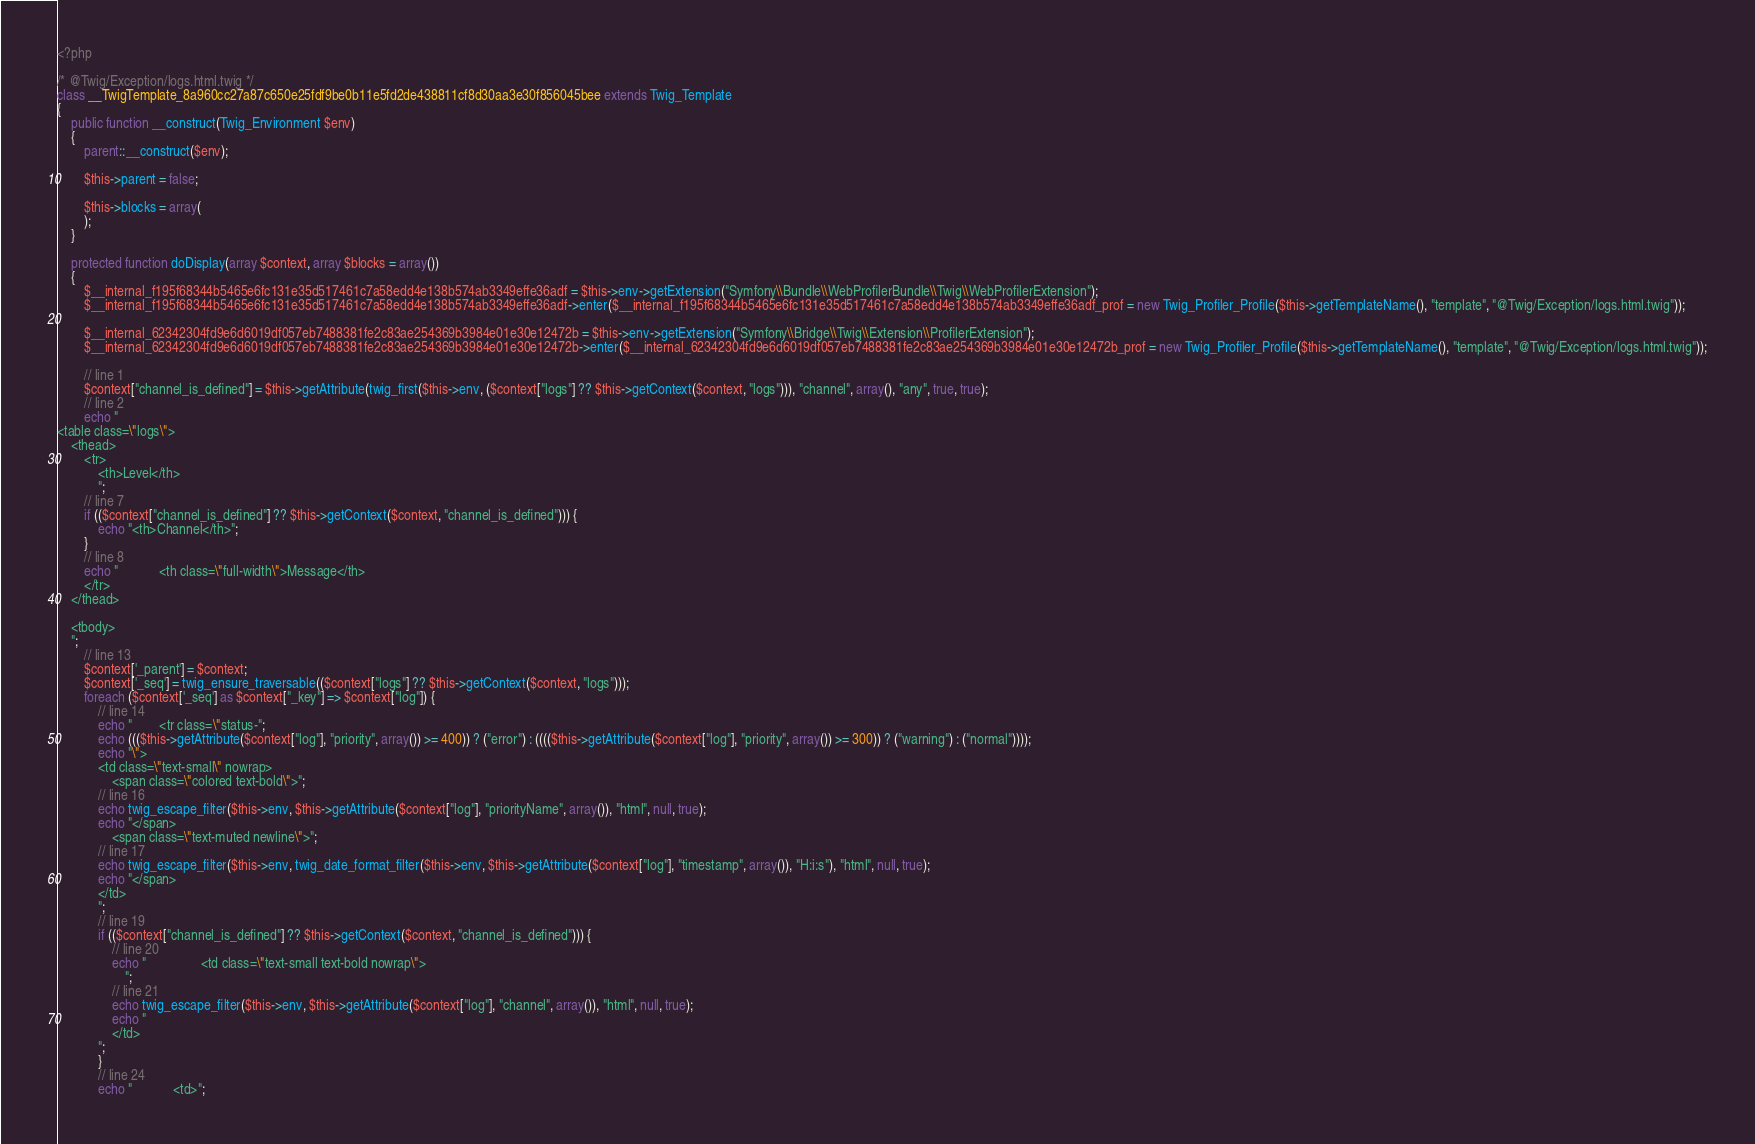<code> <loc_0><loc_0><loc_500><loc_500><_PHP_><?php

/* @Twig/Exception/logs.html.twig */
class __TwigTemplate_8a960cc27a87c650e25fdf9be0b11e5fd2de438811cf8d30aa3e30f856045bee extends Twig_Template
{
    public function __construct(Twig_Environment $env)
    {
        parent::__construct($env);

        $this->parent = false;

        $this->blocks = array(
        );
    }

    protected function doDisplay(array $context, array $blocks = array())
    {
        $__internal_f195f68344b5465e6fc131e35d517461c7a58edd4e138b574ab3349effe36adf = $this->env->getExtension("Symfony\\Bundle\\WebProfilerBundle\\Twig\\WebProfilerExtension");
        $__internal_f195f68344b5465e6fc131e35d517461c7a58edd4e138b574ab3349effe36adf->enter($__internal_f195f68344b5465e6fc131e35d517461c7a58edd4e138b574ab3349effe36adf_prof = new Twig_Profiler_Profile($this->getTemplateName(), "template", "@Twig/Exception/logs.html.twig"));

        $__internal_62342304fd9e6d6019df057eb7488381fe2c83ae254369b3984e01e30e12472b = $this->env->getExtension("Symfony\\Bridge\\Twig\\Extension\\ProfilerExtension");
        $__internal_62342304fd9e6d6019df057eb7488381fe2c83ae254369b3984e01e30e12472b->enter($__internal_62342304fd9e6d6019df057eb7488381fe2c83ae254369b3984e01e30e12472b_prof = new Twig_Profiler_Profile($this->getTemplateName(), "template", "@Twig/Exception/logs.html.twig"));

        // line 1
        $context["channel_is_defined"] = $this->getAttribute(twig_first($this->env, ($context["logs"] ?? $this->getContext($context, "logs"))), "channel", array(), "any", true, true);
        // line 2
        echo "
<table class=\"logs\">
    <thead>
        <tr>
            <th>Level</th>
            ";
        // line 7
        if (($context["channel_is_defined"] ?? $this->getContext($context, "channel_is_defined"))) {
            echo "<th>Channel</th>";
        }
        // line 8
        echo "            <th class=\"full-width\">Message</th>
        </tr>
    </thead>

    <tbody>
    ";
        // line 13
        $context['_parent'] = $context;
        $context['_seq'] = twig_ensure_traversable(($context["logs"] ?? $this->getContext($context, "logs")));
        foreach ($context['_seq'] as $context["_key"] => $context["log"]) {
            // line 14
            echo "        <tr class=\"status-";
            echo ((($this->getAttribute($context["log"], "priority", array()) >= 400)) ? ("error") : (((($this->getAttribute($context["log"], "priority", array()) >= 300)) ? ("warning") : ("normal"))));
            echo "\">
            <td class=\"text-small\" nowrap>
                <span class=\"colored text-bold\">";
            // line 16
            echo twig_escape_filter($this->env, $this->getAttribute($context["log"], "priorityName", array()), "html", null, true);
            echo "</span>
                <span class=\"text-muted newline\">";
            // line 17
            echo twig_escape_filter($this->env, twig_date_format_filter($this->env, $this->getAttribute($context["log"], "timestamp", array()), "H:i:s"), "html", null, true);
            echo "</span>
            </td>
            ";
            // line 19
            if (($context["channel_is_defined"] ?? $this->getContext($context, "channel_is_defined"))) {
                // line 20
                echo "                <td class=\"text-small text-bold nowrap\">
                    ";
                // line 21
                echo twig_escape_filter($this->env, $this->getAttribute($context["log"], "channel", array()), "html", null, true);
                echo "
                </td>
            ";
            }
            // line 24
            echo "            <td>";</code> 